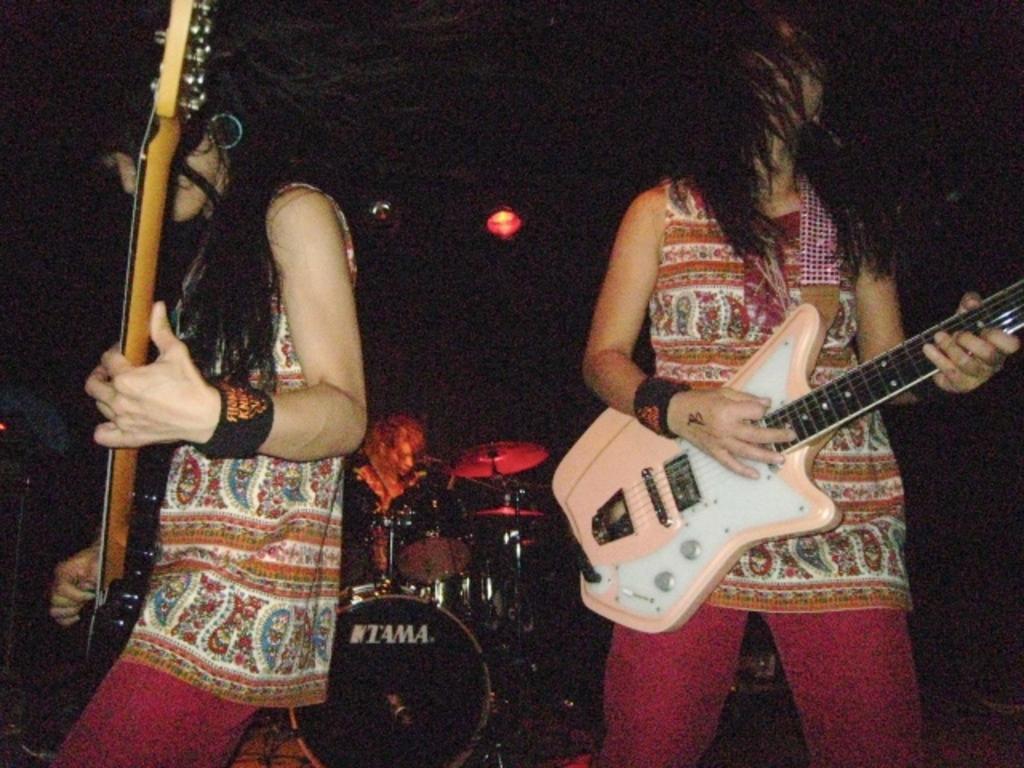In one or two sentences, can you explain what this image depicts? In this picture ,there is a woman standing on the left side playing guitar and there is a woman on the right side , she is also playing a guitar. In the center, a person sitting on the chair. There is a light on the roof. 